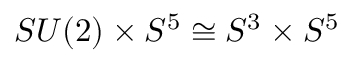Convert formula to latex. <formula><loc_0><loc_0><loc_500><loc_500>S U ( 2 ) \times S ^ { 5 } \cong S ^ { 3 } \times S ^ { 5 }</formula> 